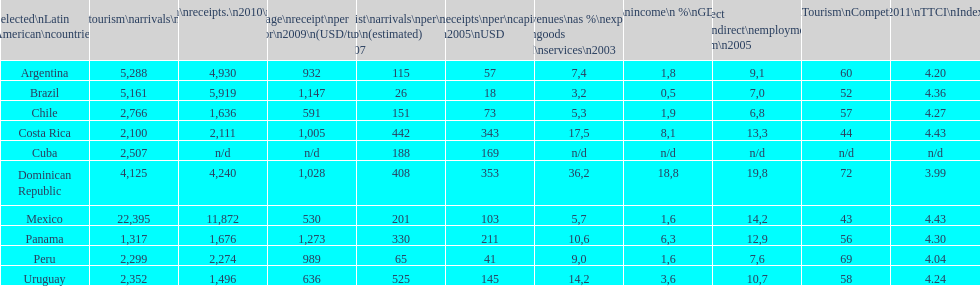What was the number of international tourist arrivals (x1000) in mexico in 2010? 22,395. 